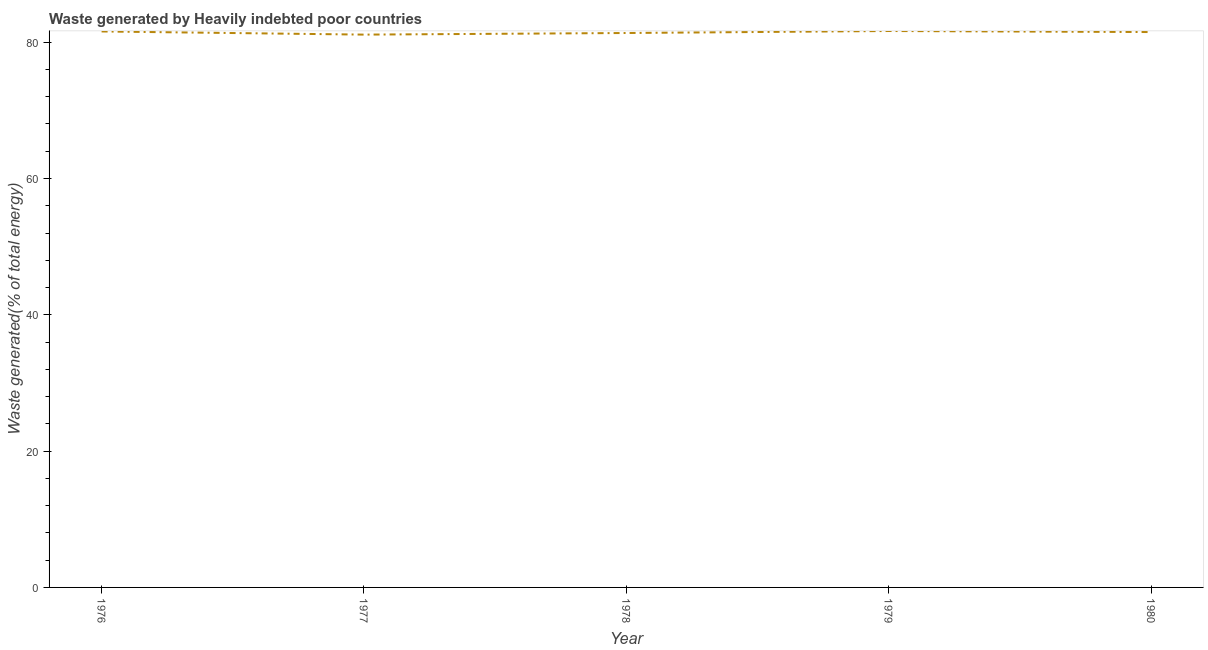What is the amount of waste generated in 1980?
Your answer should be very brief. 81.49. Across all years, what is the maximum amount of waste generated?
Your answer should be very brief. 81.64. Across all years, what is the minimum amount of waste generated?
Make the answer very short. 81.11. In which year was the amount of waste generated maximum?
Make the answer very short. 1979. In which year was the amount of waste generated minimum?
Make the answer very short. 1977. What is the sum of the amount of waste generated?
Ensure brevity in your answer.  407.16. What is the difference between the amount of waste generated in 1976 and 1980?
Your response must be concise. 0.09. What is the average amount of waste generated per year?
Your answer should be very brief. 81.43. What is the median amount of waste generated?
Provide a short and direct response. 81.49. In how many years, is the amount of waste generated greater than 44 %?
Your answer should be compact. 5. Do a majority of the years between 1977 and 1978 (inclusive) have amount of waste generated greater than 52 %?
Keep it short and to the point. Yes. What is the ratio of the amount of waste generated in 1977 to that in 1978?
Give a very brief answer. 1. Is the difference between the amount of waste generated in 1976 and 1980 greater than the difference between any two years?
Your answer should be compact. No. What is the difference between the highest and the second highest amount of waste generated?
Offer a terse response. 0.07. Is the sum of the amount of waste generated in 1977 and 1979 greater than the maximum amount of waste generated across all years?
Your answer should be very brief. Yes. What is the difference between the highest and the lowest amount of waste generated?
Ensure brevity in your answer.  0.53. Does the amount of waste generated monotonically increase over the years?
Your answer should be very brief. No. How many lines are there?
Provide a succinct answer. 1. Are the values on the major ticks of Y-axis written in scientific E-notation?
Ensure brevity in your answer.  No. Does the graph contain any zero values?
Your response must be concise. No. Does the graph contain grids?
Ensure brevity in your answer.  No. What is the title of the graph?
Ensure brevity in your answer.  Waste generated by Heavily indebted poor countries. What is the label or title of the X-axis?
Offer a very short reply. Year. What is the label or title of the Y-axis?
Provide a short and direct response. Waste generated(% of total energy). What is the Waste generated(% of total energy) in 1976?
Provide a short and direct response. 81.58. What is the Waste generated(% of total energy) in 1977?
Keep it short and to the point. 81.11. What is the Waste generated(% of total energy) of 1978?
Provide a short and direct response. 81.35. What is the Waste generated(% of total energy) of 1979?
Give a very brief answer. 81.64. What is the Waste generated(% of total energy) of 1980?
Provide a succinct answer. 81.49. What is the difference between the Waste generated(% of total energy) in 1976 and 1977?
Give a very brief answer. 0.46. What is the difference between the Waste generated(% of total energy) in 1976 and 1978?
Offer a very short reply. 0.23. What is the difference between the Waste generated(% of total energy) in 1976 and 1979?
Ensure brevity in your answer.  -0.07. What is the difference between the Waste generated(% of total energy) in 1976 and 1980?
Ensure brevity in your answer.  0.09. What is the difference between the Waste generated(% of total energy) in 1977 and 1978?
Ensure brevity in your answer.  -0.24. What is the difference between the Waste generated(% of total energy) in 1977 and 1979?
Provide a short and direct response. -0.53. What is the difference between the Waste generated(% of total energy) in 1977 and 1980?
Offer a very short reply. -0.37. What is the difference between the Waste generated(% of total energy) in 1978 and 1979?
Offer a terse response. -0.29. What is the difference between the Waste generated(% of total energy) in 1978 and 1980?
Your answer should be very brief. -0.14. What is the difference between the Waste generated(% of total energy) in 1979 and 1980?
Offer a very short reply. 0.15. What is the ratio of the Waste generated(% of total energy) in 1976 to that in 1977?
Provide a succinct answer. 1.01. What is the ratio of the Waste generated(% of total energy) in 1977 to that in 1980?
Give a very brief answer. 0.99. What is the ratio of the Waste generated(% of total energy) in 1978 to that in 1979?
Offer a very short reply. 1. What is the ratio of the Waste generated(% of total energy) in 1978 to that in 1980?
Keep it short and to the point. 1. What is the ratio of the Waste generated(% of total energy) in 1979 to that in 1980?
Ensure brevity in your answer.  1. 